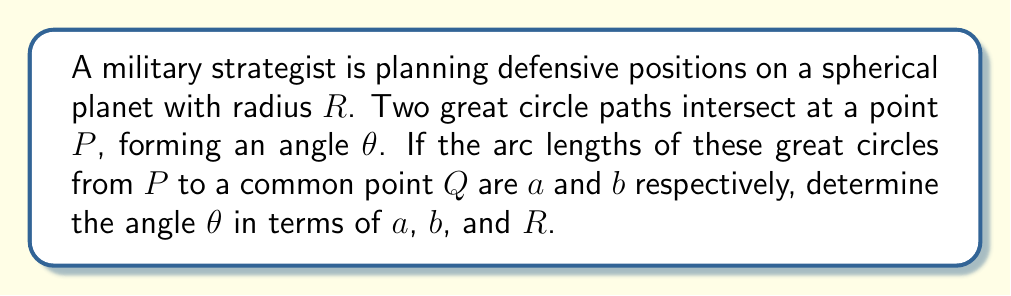Show me your answer to this math problem. Let's approach this step-by-step using spherical trigonometry:

1) In spherical geometry, great circles are the analogues of straight lines in planar geometry. They are the intersections of the sphere with planes passing through the center of the sphere.

2) The angle between two great circles at their point of intersection is equal to the angle between the planes containing these great circles.

3) Consider the spherical triangle formed by points $P$, $Q$, and the center of the sphere $O$. Let's call the angles at these points $\theta$, $\gamma$, and $\alpha$ respectively.

4) The sides of this spherical triangle are arcs of great circles. Their lengths are:
   $PQ = c$ (unknown)
   $OQ = R$ (radius)
   $OP = R$ (radius)

5) The central angles corresponding to arcs $a$ and $b$ are $\frac{a}{R}$ and $\frac{b}{R}$ respectively.

6) We can apply the spherical law of cosines to this triangle:

   $$\cos(\frac{c}{R}) = \cos(\frac{a}{R})\cos(\frac{b}{R}) + \sin(\frac{a}{R})\sin(\frac{b}{R})\cos(\theta)$$

7) Rearranging this equation to isolate $\cos(\theta)$:

   $$\cos(\theta) = \frac{\cos(\frac{c}{R}) - \cos(\frac{a}{R})\cos(\frac{b}{R})}{\sin(\frac{a}{R})\sin(\frac{b}{R})}$$

8) To eliminate $c$, we can use another form of the spherical law of cosines:

   $$\cos(\frac{c}{R}) = \cos(\frac{a}{R})\cos(\frac{b}{R}) + \sin(\frac{a}{R})\sin(\frac{b}{R})\cos(\theta)$$

9) Substituting this into our equation for $\cos(\theta)$:

   $$\cos(\theta) = \frac{[\cos(\frac{a}{R})\cos(\frac{b}{R}) + \sin(\frac{a}{R})\sin(\frac{b}{R})\cos(\theta)] - \cos(\frac{a}{R})\cos(\frac{b}{R})}{\sin(\frac{a}{R})\sin(\frac{b}{R})}$$

10) Simplifying:

    $$\cos(\theta) = \cos(\theta)$$

11) While this is true, it doesn't give us a useful expression for $\theta$. We need to go back to step 7 and solve for $\theta$ directly:

    $$\theta = \arccos(\frac{\cos(\frac{c}{R}) - \cos(\frac{a}{R})\cos(\frac{b}{R})}{\sin(\frac{a}{R})\sin(\frac{b}{R})})$$

This gives us the angle of intersection in terms of $a$, $b$, $c$, and $R$.
Answer: $\theta = \arccos(\frac{\cos(\frac{c}{R}) - \cos(\frac{a}{R})\cos(\frac{b}{R})}{\sin(\frac{a}{R})\sin(\frac{b}{R})})$ 